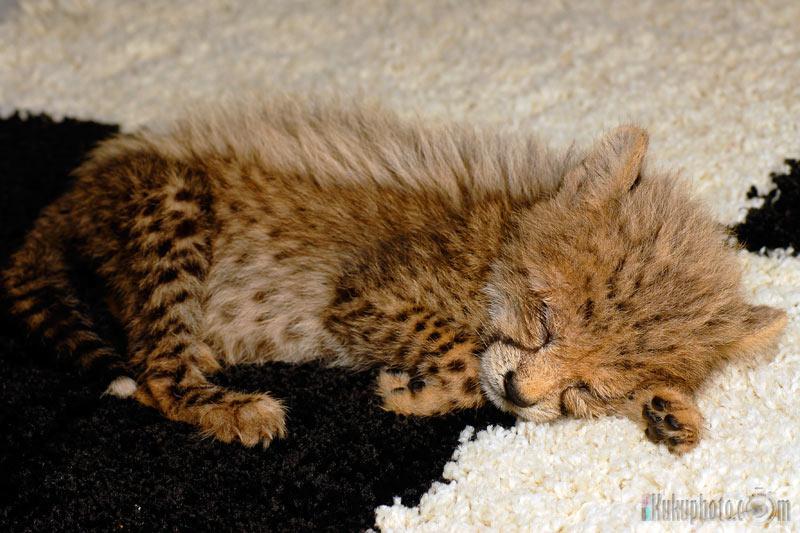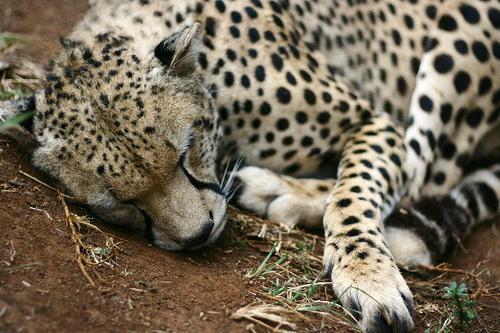The first image is the image on the left, the second image is the image on the right. Analyze the images presented: Is the assertion "A baby leopard is laying next to its mom." valid? Answer yes or no. No. The first image is the image on the left, the second image is the image on the right. Assess this claim about the two images: "In the image to the right, a cheetah kitten is laying down, looking forwards.". Correct or not? Answer yes or no. No. 